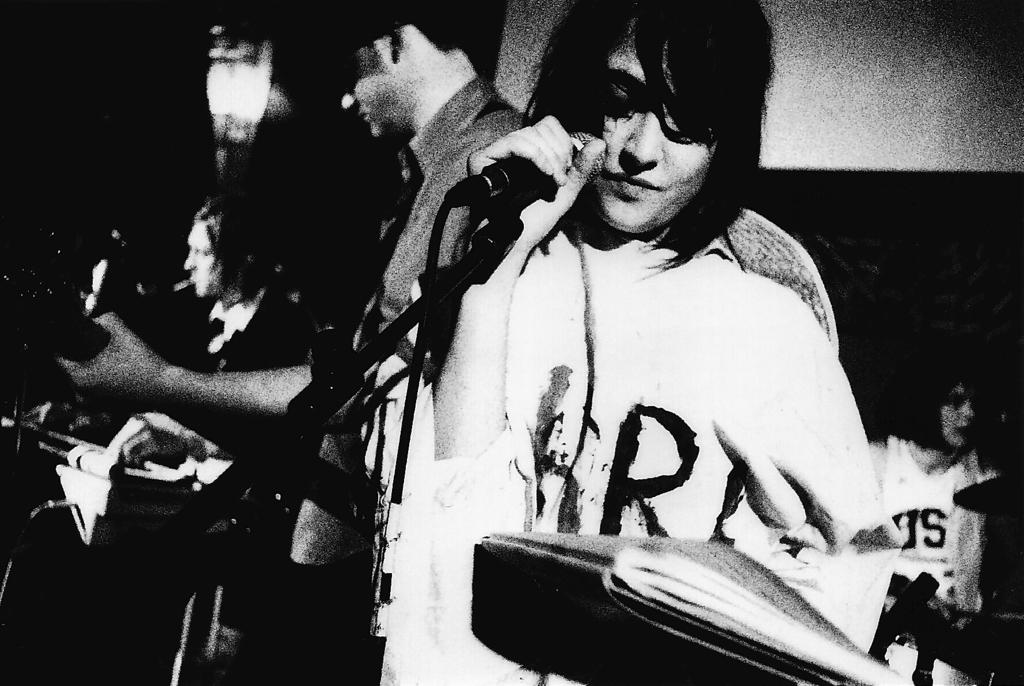What is the color scheme of the image? The image is black and white. Who is the main subject in the image? There is a woman in the image. What is the woman doing in the image? The woman is standing and holding a mic and a book. What can be seen in the background of the image? There are men in the background of the image, and they are playing musical instruments. There is also a wall in the background. What type of nerve can be seen in the image? There is no nerve present in the image. What time does the watch in the image show? There is no watch present in the image. 